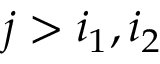<formula> <loc_0><loc_0><loc_500><loc_500>j > i _ { 1 } , i _ { 2 }</formula> 